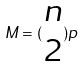<formula> <loc_0><loc_0><loc_500><loc_500>M = ( \begin{matrix} n \\ 2 \end{matrix} ) p</formula> 